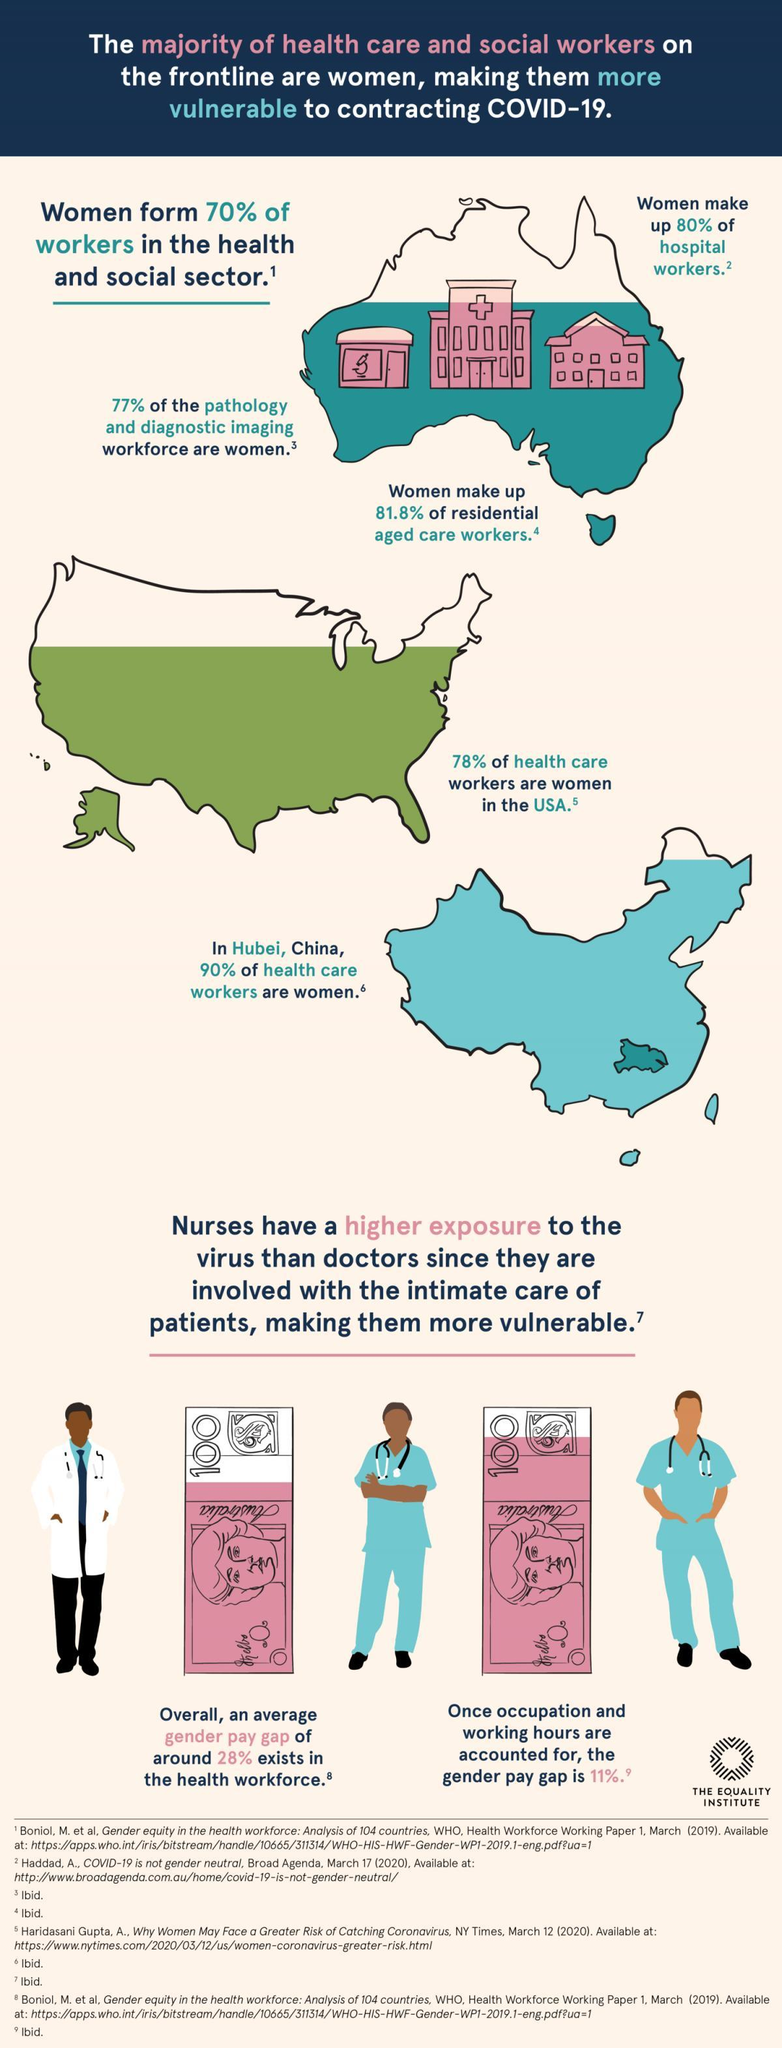What percentage of the pathology and diagnostic imaging workforce are not women?
Answer the question with a short phrase. 23% What percentage of workers in the health and social sector are not women? 30% What percentage of health care workers in Hubei are not women? 10% What percentage of health care workers in the USA are not women? 28% What percentage of women are not hospital workers? 20% 